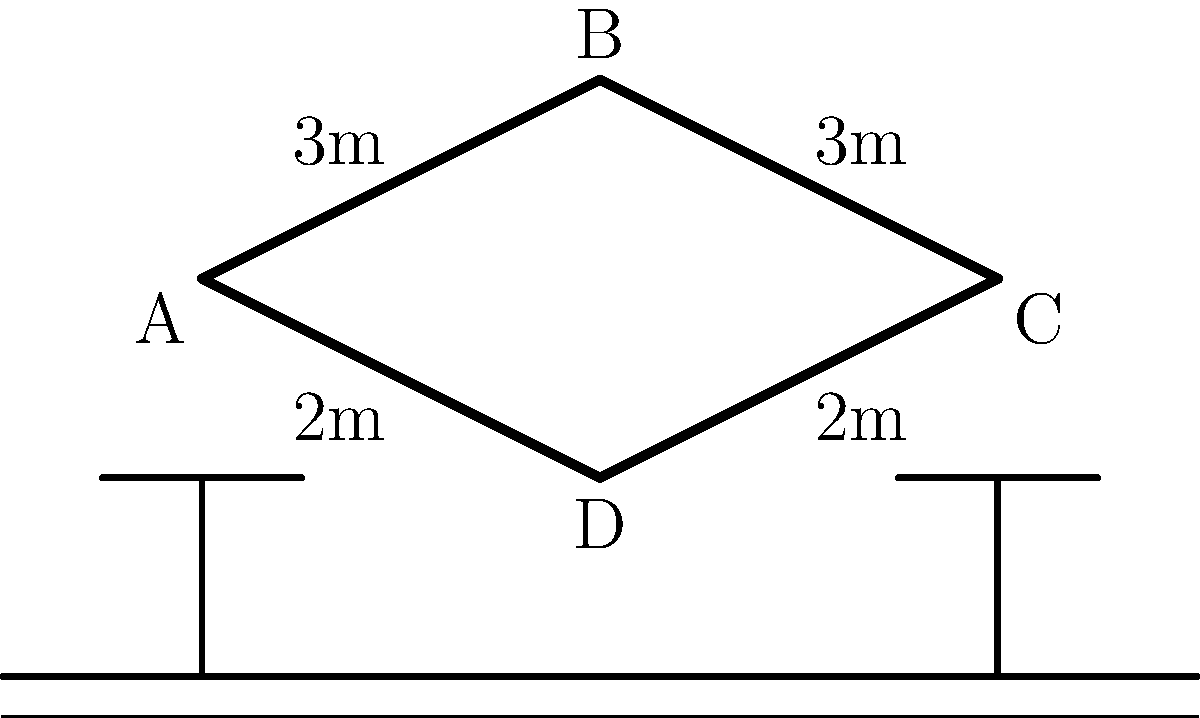A traditional boomerang is designed with specific angles to maximize its flight path and return capability. If the boomerang is thrown from point A and follows the path A-B-C-D-A, what is the total distance traveled by the boomerang in meters? To solve this problem, we need to calculate the perimeter of the boomerang shape:

1. Identify the lengths of each side:
   - AB = 3m
   - BC = 3m
   - CD = 2m
   - DA = 2m

2. Calculate the total distance by adding all sides:
   Total distance = AB + BC + CD + DA
   Total distance = 3m + 3m + 2m + 2m
   Total distance = 10m

The boomerang travels along all four sides of the shape, completing a full circuit.
Answer: 10m 